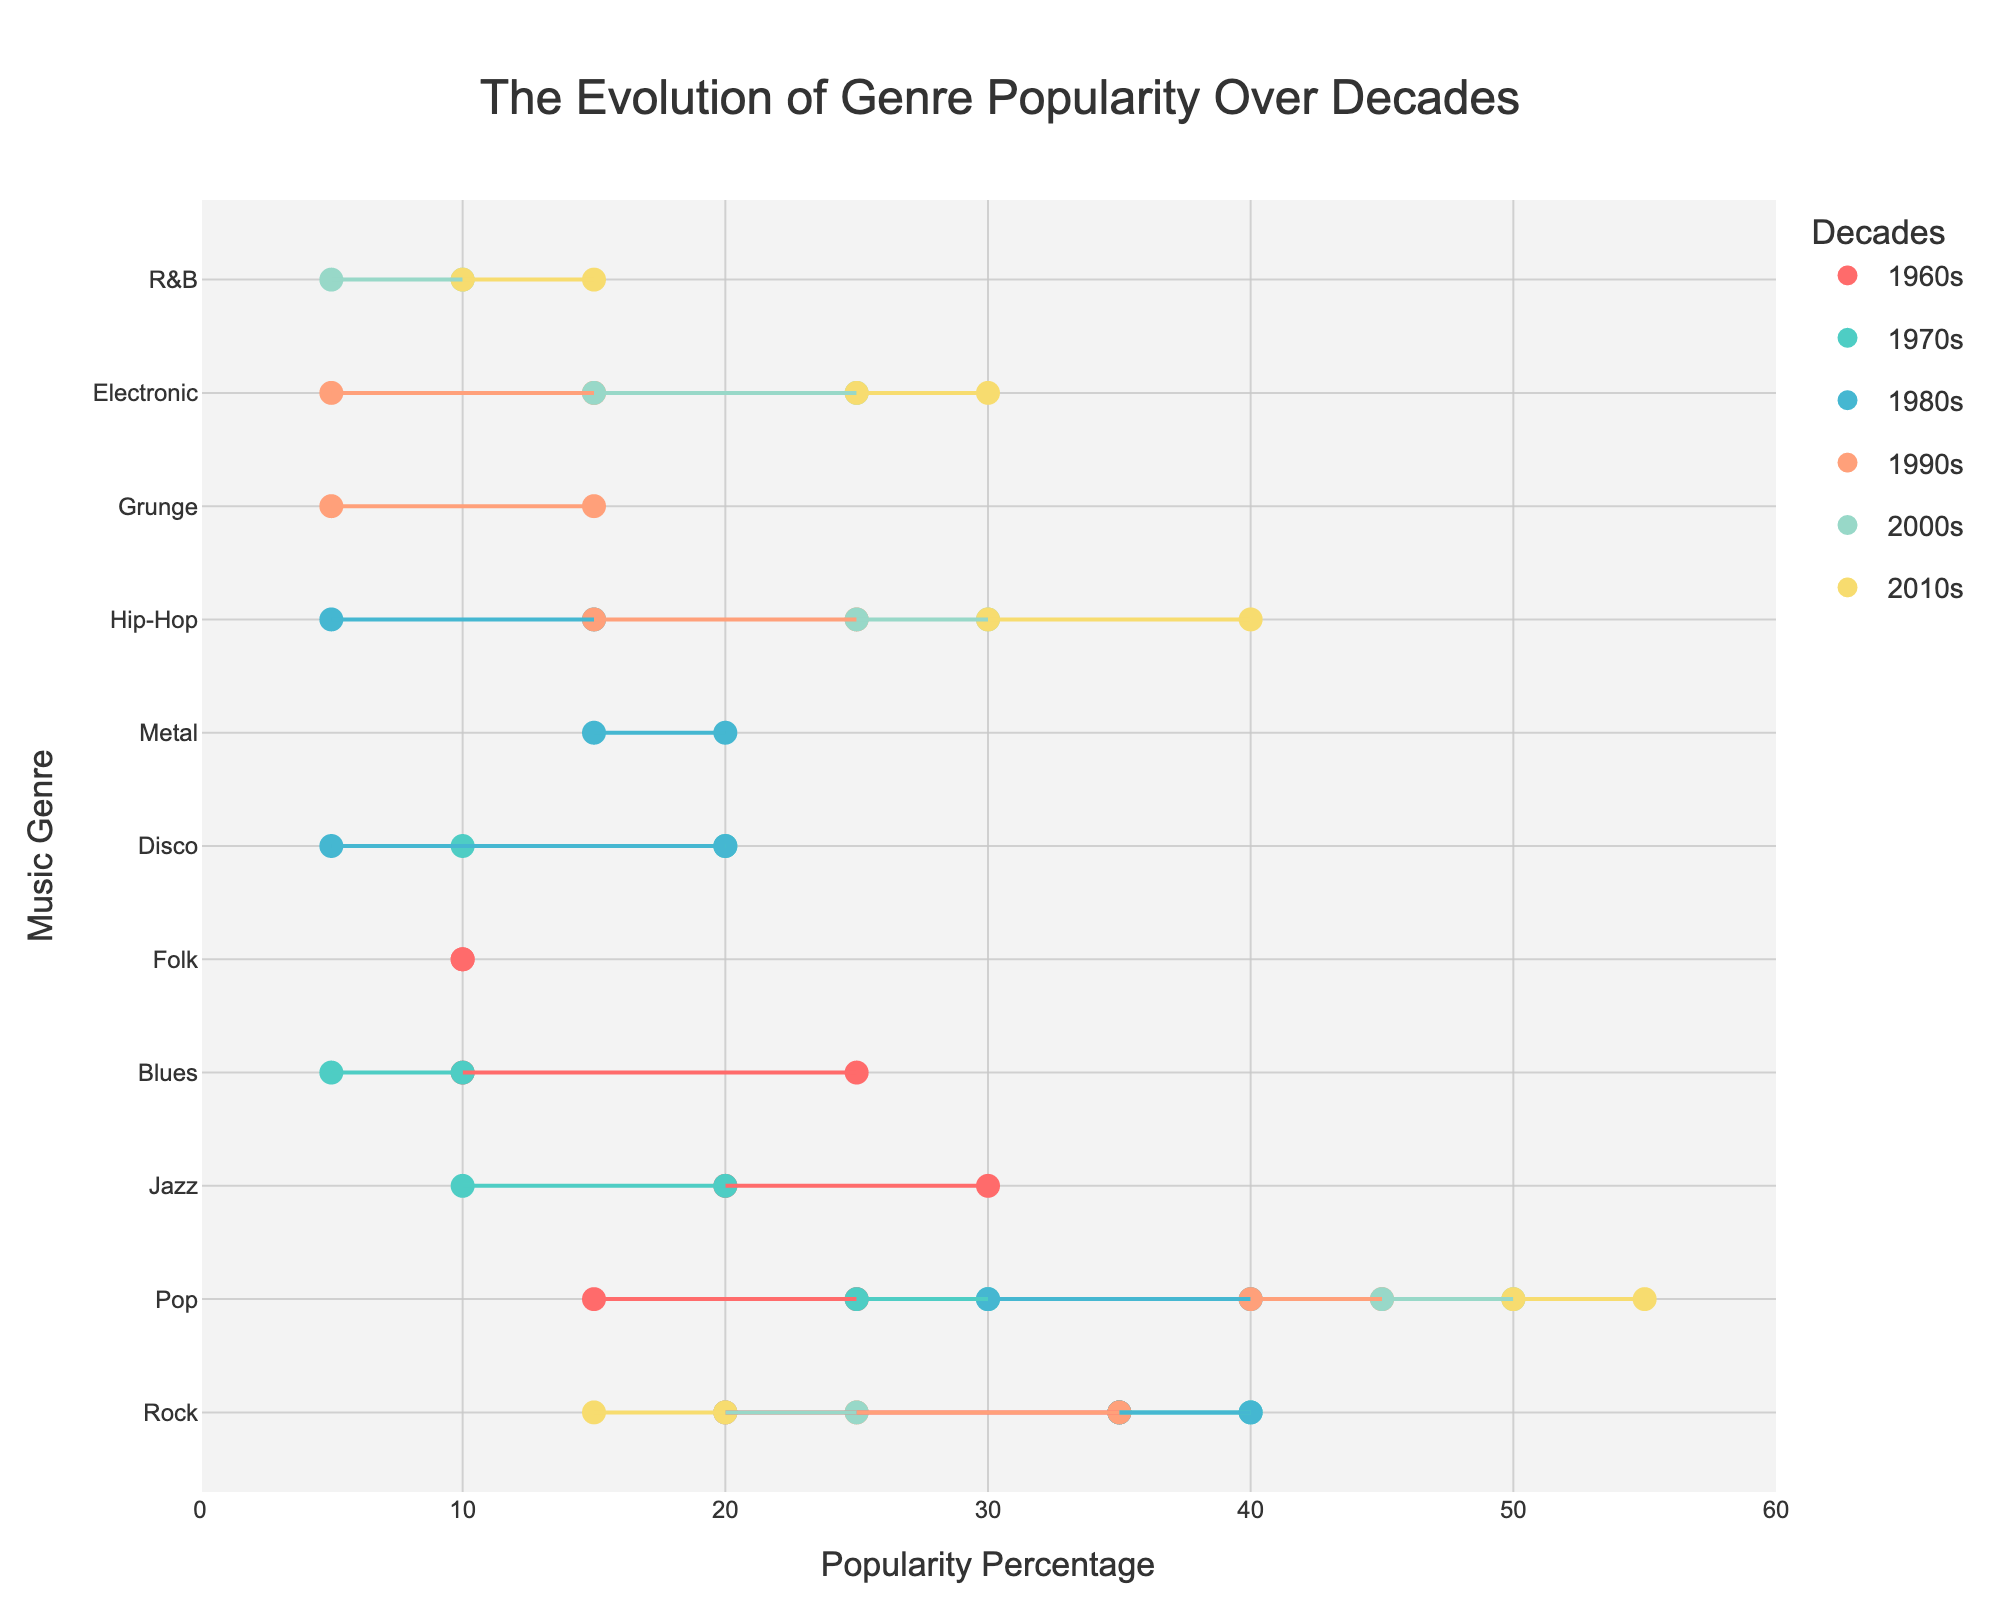What's the title of the plot? The title is usually prominently displayed at the top of the plot. In this case, it is "The Evolution of Genre Popularity Over Decades".
Answer: The Evolution of Genre Popularity Over Decades What are the axes labels on the plot? The axes labels are defined in the plot layout. The x-axis is labeled "Popularity Percentage" and the y-axis is labeled "Music Genre".
Answer: Popularity Percentage, Music Genre Which genre maintained a constant popularity percentage from the 1960s to the 2010s? By comparing the start and end percentages across decades, we observe that "Folk" has maintained a constant popularity percentage of 10% in the 1960s.
Answer: Folk In which decade did Hip-Hop see the highest increase in popularity percentage? To find the highest increase for Hip-Hop, look at the difference between the start and end percentages in each decade. The largest increase is from the 2010s where it rises from 30% to 40%.
Answer: 2010s Which genre saw a decline in popularity percentage from the 1980s to the 1990s? By comparing the end percentage in the 1980s to the start percentage in the 1990s, we see that "Rock" decreased from 35% to 25%.
Answer: Rock What is the total popularity percentage of new genres introduced in each decade till the 2010s? Sum up the start percentages of genres introduced in the specific decades. For the 1970s (Disco: 10%), 1980s (Hip-Hop: 5%, Metal: 15%), 1990s (Grunge: 5%, Electronic: 5%), 2000s (R&B: 5%).
Answer: 40% Which genres decreased in popularity from the 1960s to the 1970s by more than 10%? We subtract the 1970s start percentages from the 1960s end percentages. Jazz decreased by 10% (30% to 20%) and Blues decreased by 15% (25% to 10%).
Answer: Jazz, Blues Between the 1980s and the 1990s, which genre saw the highest increase in percentage? By comparing end and start percentages of genres, Hip-Hop increased from 15% (1980s) to 25% (1990s), which is a 10% increase.
Answer: Hip-Hop Which genre was equally popular in both the 1990s and 2000s? By checking the end percentage of the 1990s and the start percentage of the 2000s, we see that "Pop" maintained its popularity at 45%.
Answer: Pop 